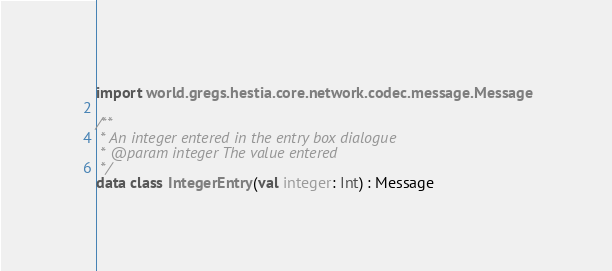<code> <loc_0><loc_0><loc_500><loc_500><_Kotlin_>import world.gregs.hestia.core.network.codec.message.Message

/**
 * An integer entered in the entry box dialogue
 * @param integer The value entered
 */
data class IntegerEntry(val integer: Int) : Message</code> 